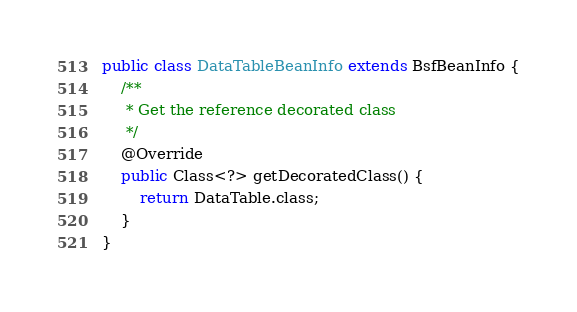<code> <loc_0><loc_0><loc_500><loc_500><_Java_>public class DataTableBeanInfo extends BsfBeanInfo {
	/**
	 * Get the reference decorated class
	 */
	@Override
	public Class<?> getDecoratedClass() {
		return DataTable.class;
	}
}</code> 